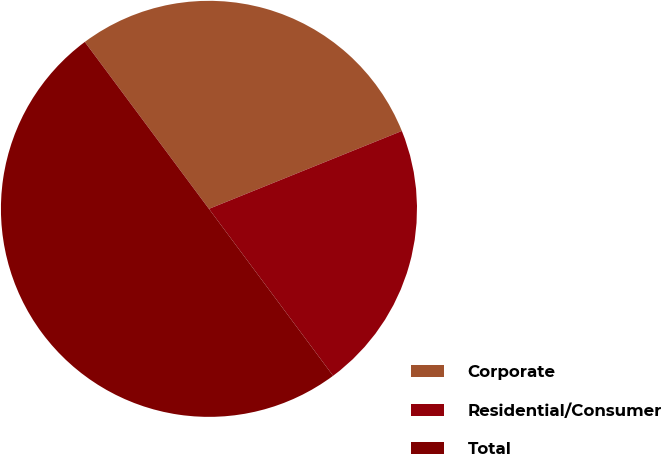<chart> <loc_0><loc_0><loc_500><loc_500><pie_chart><fcel>Corporate<fcel>Residential/Consumer<fcel>Total<nl><fcel>29.07%<fcel>20.93%<fcel>50.0%<nl></chart> 